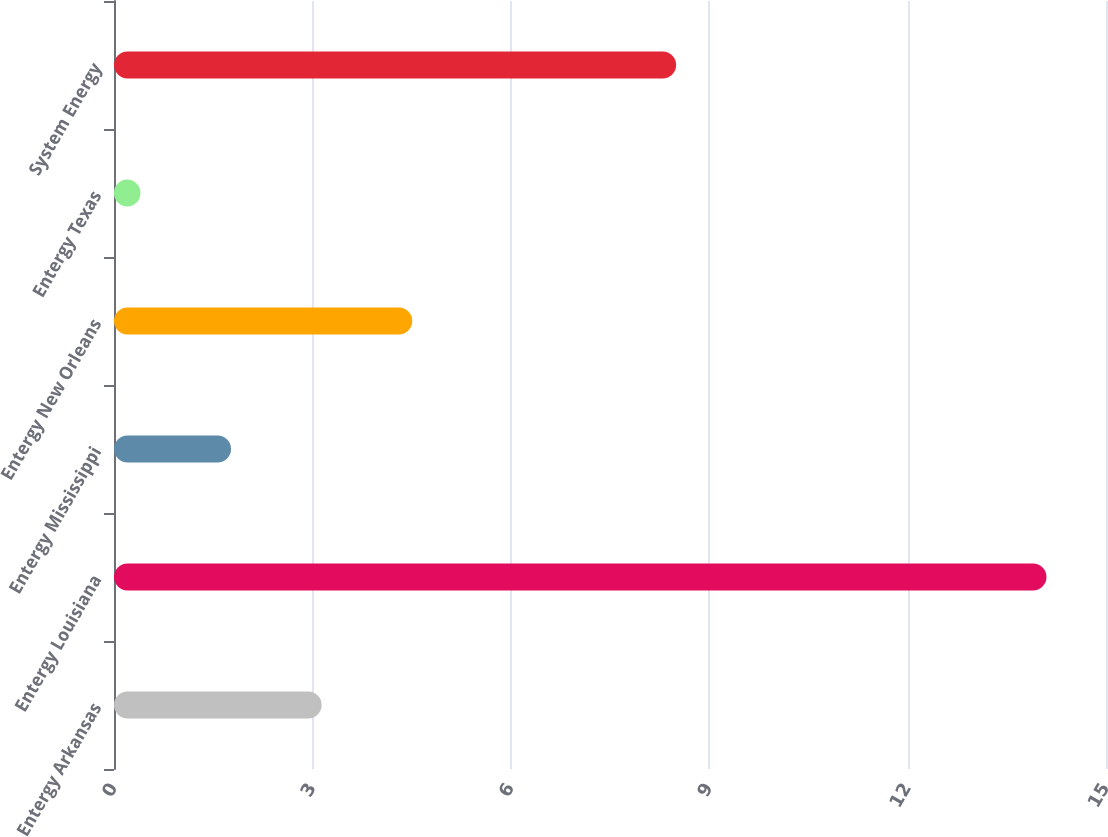Convert chart. <chart><loc_0><loc_0><loc_500><loc_500><bar_chart><fcel>Entergy Arkansas<fcel>Entergy Louisiana<fcel>Entergy Mississippi<fcel>Entergy New Orleans<fcel>Entergy Texas<fcel>System Energy<nl><fcel>3.14<fcel>14.1<fcel>1.77<fcel>4.51<fcel>0.4<fcel>8.5<nl></chart> 